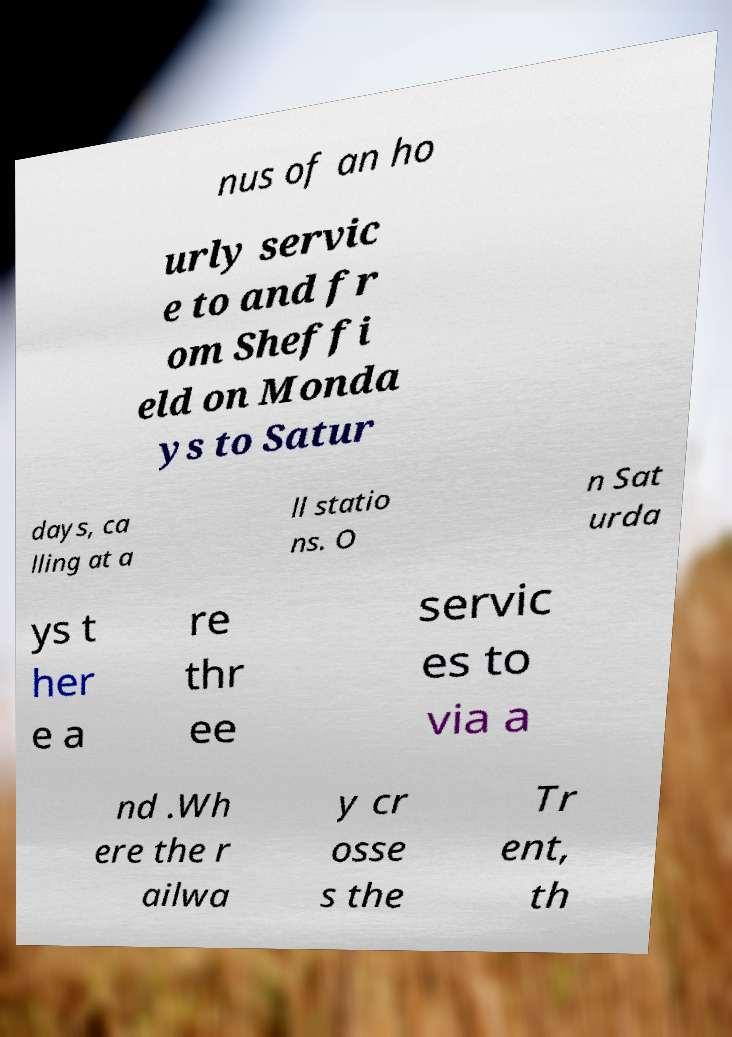There's text embedded in this image that I need extracted. Can you transcribe it verbatim? nus of an ho urly servic e to and fr om Sheffi eld on Monda ys to Satur days, ca lling at a ll statio ns. O n Sat urda ys t her e a re thr ee servic es to via a nd .Wh ere the r ailwa y cr osse s the Tr ent, th 